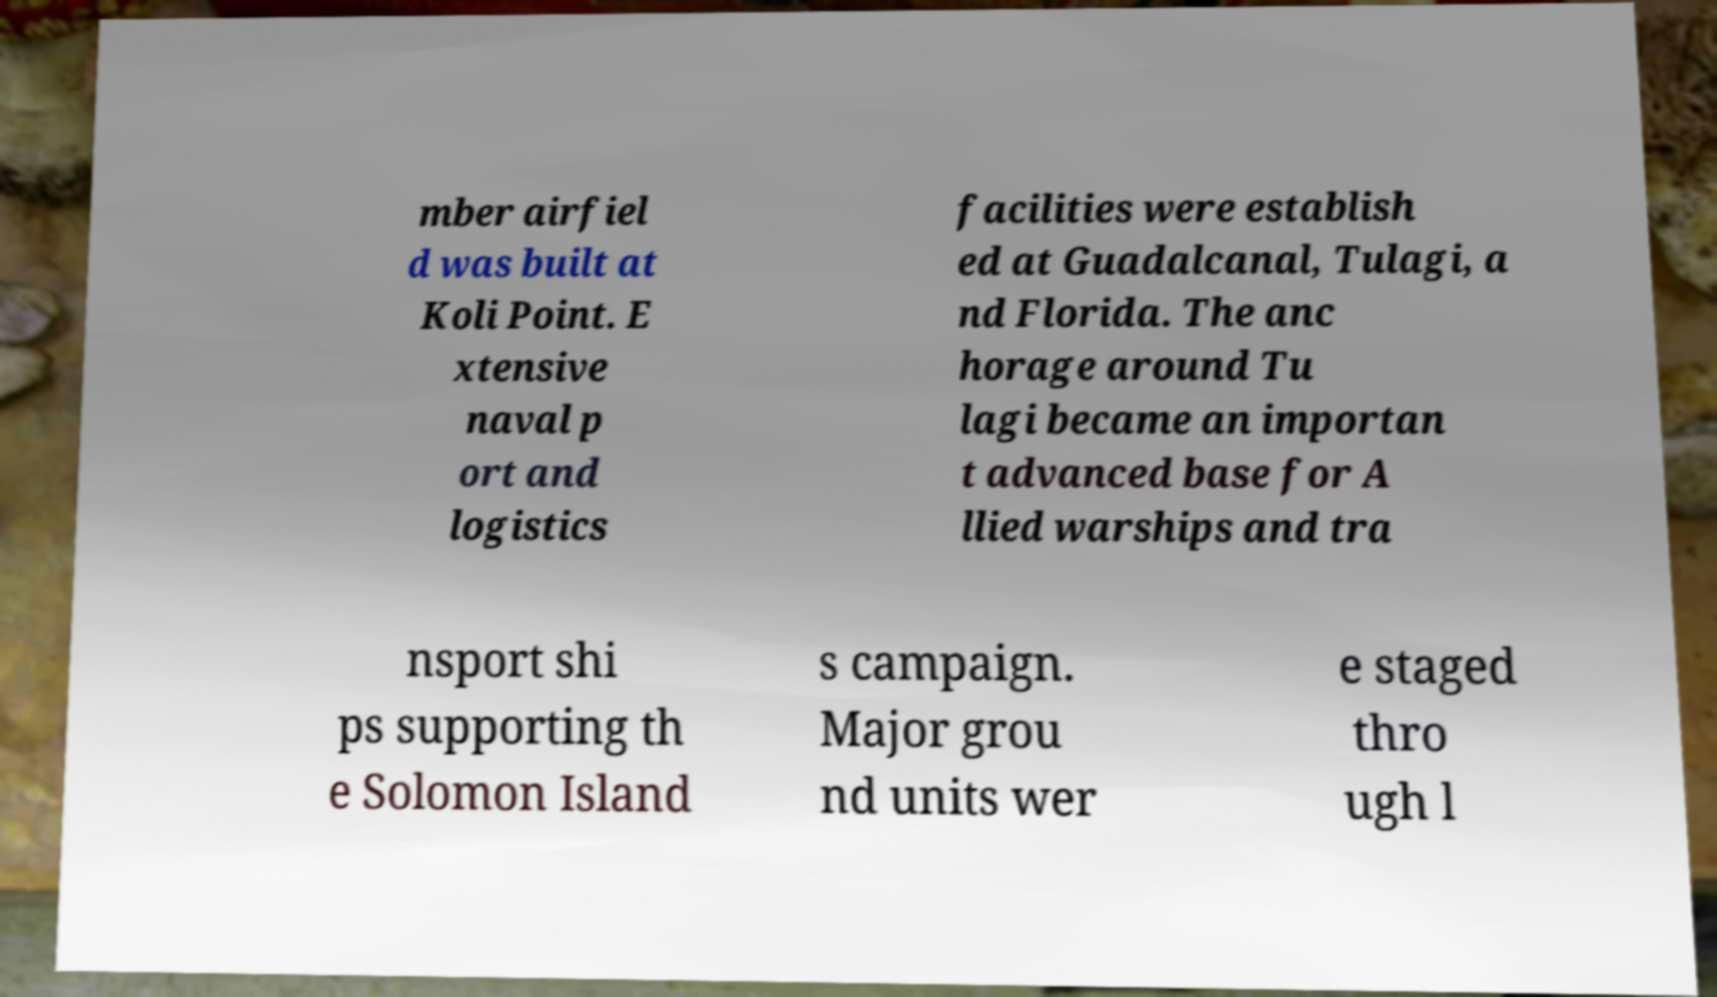Could you extract and type out the text from this image? mber airfiel d was built at Koli Point. E xtensive naval p ort and logistics facilities were establish ed at Guadalcanal, Tulagi, a nd Florida. The anc horage around Tu lagi became an importan t advanced base for A llied warships and tra nsport shi ps supporting th e Solomon Island s campaign. Major grou nd units wer e staged thro ugh l 